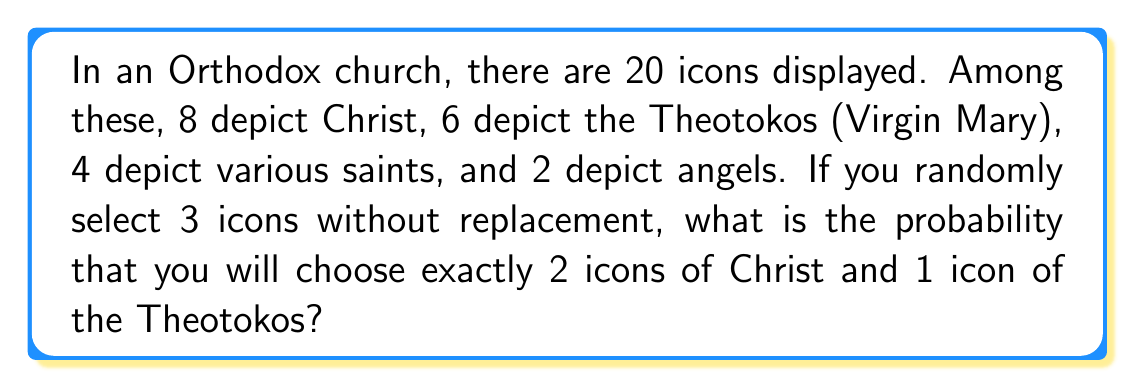Can you solve this math problem? Let's approach this step-by-step:

1) First, we need to calculate the total number of ways to select 3 icons out of 20. This is given by the combination formula:

   $$\binom{20}{3} = \frac{20!}{3!(20-3)!} = \frac{20!}{3!17!} = 1140$$

2) Now, we need to calculate the number of ways to select 2 Christ icons out of 8 and 1 Theotokos icon out of 6:

   - Selecting 2 Christ icons: $\binom{8}{2} = \frac{8!}{2!6!} = 28$
   - Selecting 1 Theotokos icon: $\binom{6}{1} = 6$

3) By the multiplication principle, the total number of favorable outcomes is:

   $$28 \times 6 = 168$$

4) The probability is then the number of favorable outcomes divided by the total number of possible outcomes:

   $$P(\text{2 Christ, 1 Theotokos}) = \frac{168}{1140} = \frac{7}{47} \approx 0.1489$$
Answer: $\frac{7}{47}$ 